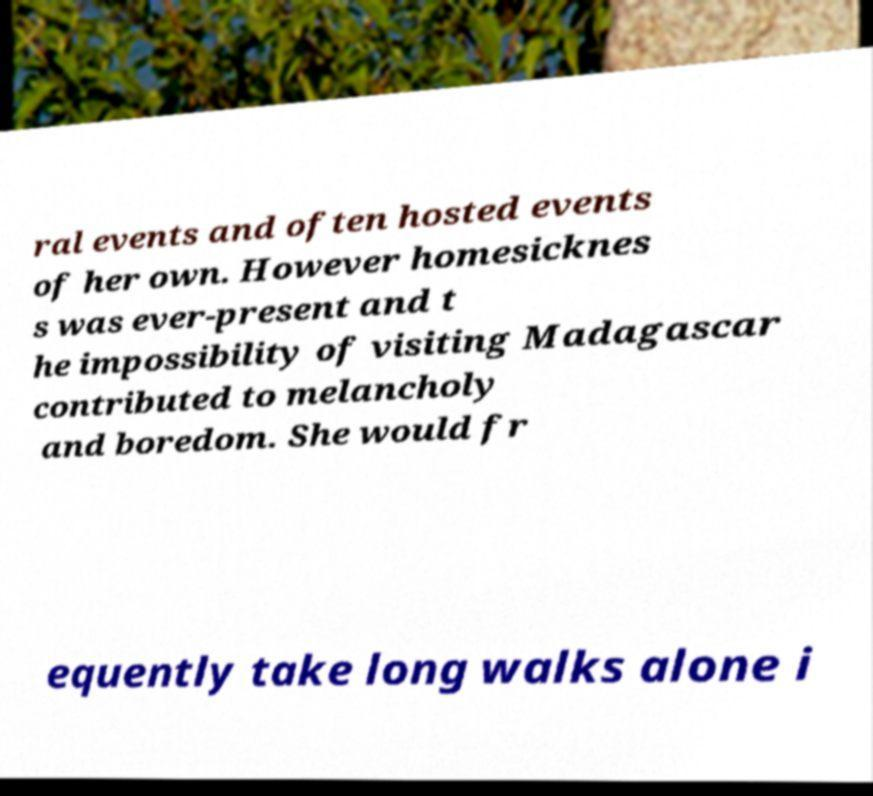Please read and relay the text visible in this image. What does it say? ral events and often hosted events of her own. However homesicknes s was ever-present and t he impossibility of visiting Madagascar contributed to melancholy and boredom. She would fr equently take long walks alone i 